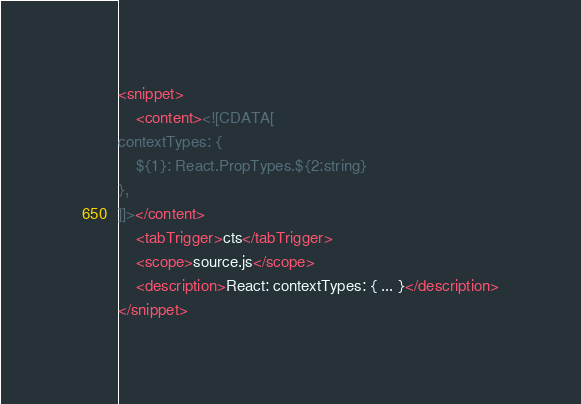Convert code to text. <code><loc_0><loc_0><loc_500><loc_500><_XML_><snippet>
    <content><![CDATA[
contextTypes: {
	${1}: React.PropTypes.${2:string}
},
]]></content>
    <tabTrigger>cts</tabTrigger>
    <scope>source.js</scope>
    <description>React: contextTypes: { ... }</description>
</snippet>
</code> 